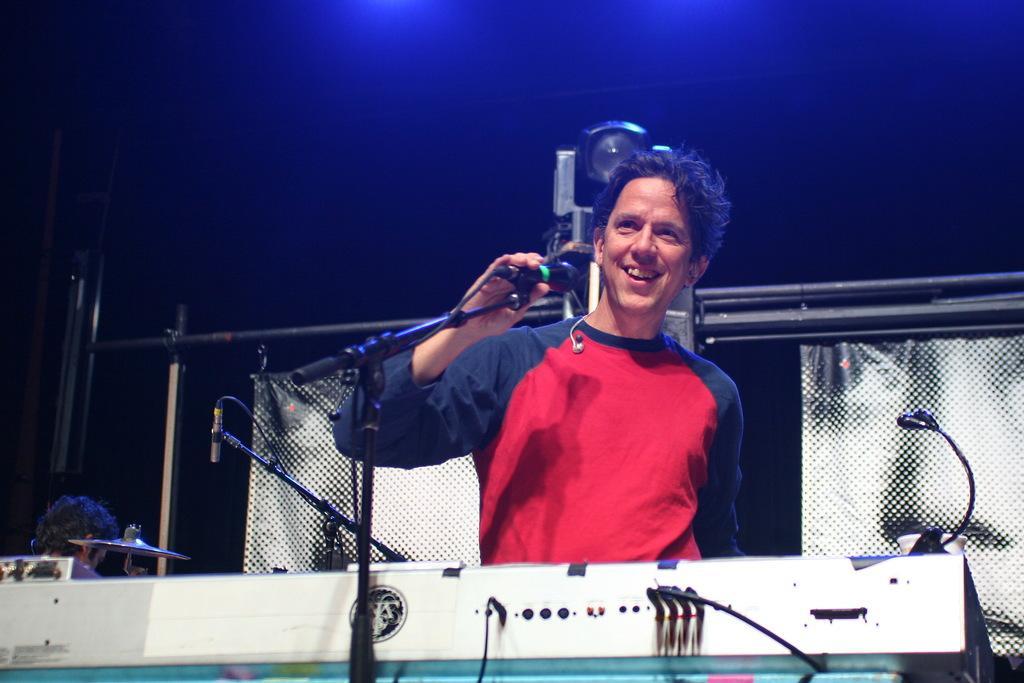Describe this image in one or two sentences. In this image we can see a person holding a mic with a mic stand. Also there is a musical instrument. Also there is a person. In the back there is a cymbal. And there is a mic with mic stand. There are rods. There are curtains. In the background it is dark. 